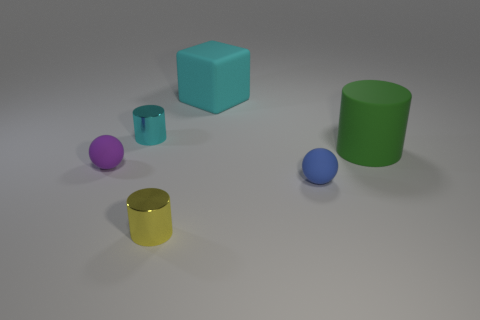What is the tiny cyan cylinder made of?
Make the answer very short. Metal. There is a large thing that is to the right of the tiny ball that is on the right side of the purple object; what shape is it?
Provide a succinct answer. Cylinder. What number of other objects are the same shape as the blue object?
Offer a very short reply. 1. Are there any tiny shiny things right of the large green rubber object?
Your answer should be compact. No. What is the color of the big cylinder?
Keep it short and to the point. Green. Does the matte cylinder have the same color as the tiny shiny object in front of the big matte cylinder?
Offer a very short reply. No. Are there any shiny cylinders of the same size as the cyan cube?
Keep it short and to the point. No. There is a cylinder that is the same color as the large block; what size is it?
Offer a terse response. Small. What is the material of the small ball that is on the right side of the large cyan object?
Your answer should be very brief. Rubber. Is the number of cyan matte things that are behind the large cyan thing the same as the number of purple spheres right of the blue ball?
Your response must be concise. Yes. 